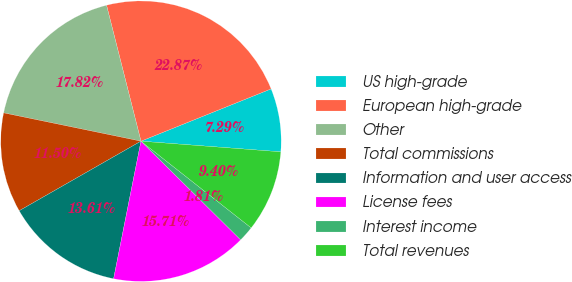<chart> <loc_0><loc_0><loc_500><loc_500><pie_chart><fcel>US high-grade<fcel>European high-grade<fcel>Other<fcel>Total commissions<fcel>Information and user access<fcel>License fees<fcel>Interest income<fcel>Total revenues<nl><fcel>7.29%<fcel>22.87%<fcel>17.82%<fcel>11.5%<fcel>13.61%<fcel>15.71%<fcel>1.81%<fcel>9.4%<nl></chart> 